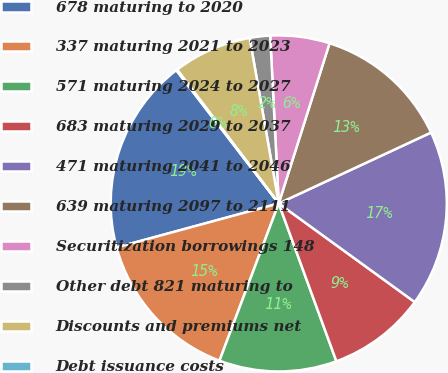<chart> <loc_0><loc_0><loc_500><loc_500><pie_chart><fcel>678 maturing to 2020<fcel>337 maturing 2021 to 2023<fcel>571 maturing 2024 to 2027<fcel>683 maturing 2029 to 2037<fcel>471 maturing 2041 to 2046<fcel>639 maturing 2097 to 2111<fcel>Securitization borrowings 148<fcel>Other debt 821 maturing to<fcel>Discounts and premiums net<fcel>Debt issuance costs<nl><fcel>18.79%<fcel>15.05%<fcel>11.31%<fcel>9.44%<fcel>16.92%<fcel>13.18%<fcel>5.7%<fcel>1.96%<fcel>7.57%<fcel>0.09%<nl></chart> 